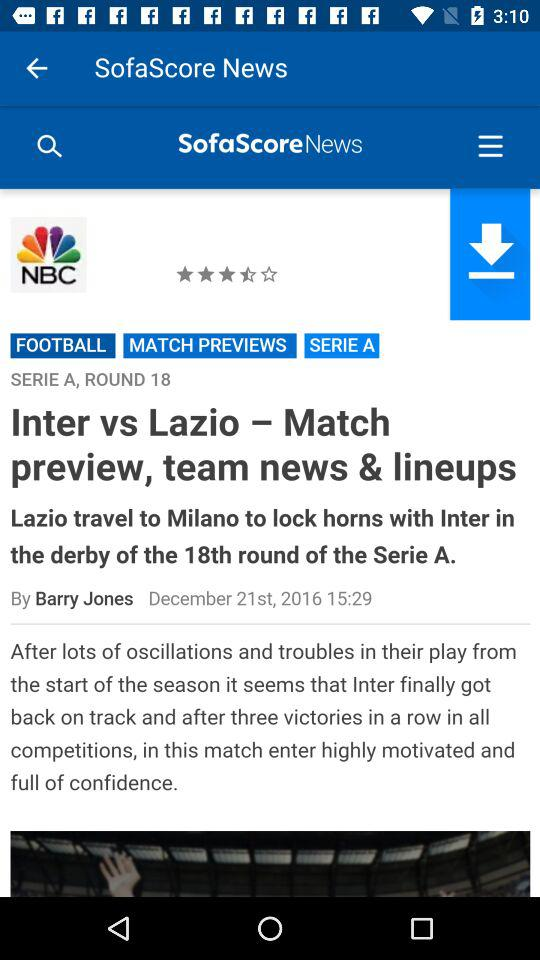What is the mentioned time? The mentioned time is 15:29. 